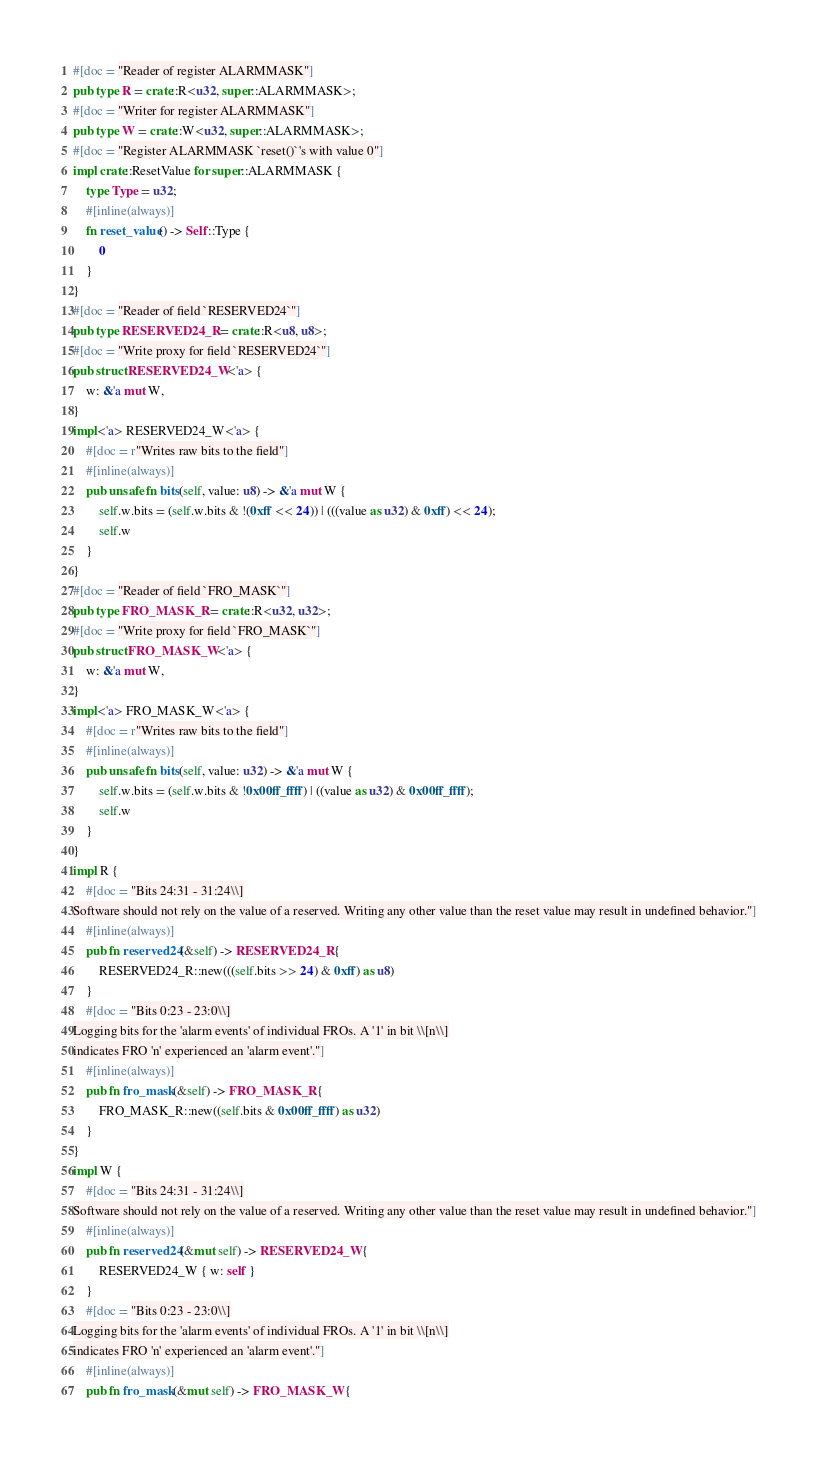<code> <loc_0><loc_0><loc_500><loc_500><_Rust_>#[doc = "Reader of register ALARMMASK"]
pub type R = crate::R<u32, super::ALARMMASK>;
#[doc = "Writer for register ALARMMASK"]
pub type W = crate::W<u32, super::ALARMMASK>;
#[doc = "Register ALARMMASK `reset()`'s with value 0"]
impl crate::ResetValue for super::ALARMMASK {
    type Type = u32;
    #[inline(always)]
    fn reset_value() -> Self::Type {
        0
    }
}
#[doc = "Reader of field `RESERVED24`"]
pub type RESERVED24_R = crate::R<u8, u8>;
#[doc = "Write proxy for field `RESERVED24`"]
pub struct RESERVED24_W<'a> {
    w: &'a mut W,
}
impl<'a> RESERVED24_W<'a> {
    #[doc = r"Writes raw bits to the field"]
    #[inline(always)]
    pub unsafe fn bits(self, value: u8) -> &'a mut W {
        self.w.bits = (self.w.bits & !(0xff << 24)) | (((value as u32) & 0xff) << 24);
        self.w
    }
}
#[doc = "Reader of field `FRO_MASK`"]
pub type FRO_MASK_R = crate::R<u32, u32>;
#[doc = "Write proxy for field `FRO_MASK`"]
pub struct FRO_MASK_W<'a> {
    w: &'a mut W,
}
impl<'a> FRO_MASK_W<'a> {
    #[doc = r"Writes raw bits to the field"]
    #[inline(always)]
    pub unsafe fn bits(self, value: u32) -> &'a mut W {
        self.w.bits = (self.w.bits & !0x00ff_ffff) | ((value as u32) & 0x00ff_ffff);
        self.w
    }
}
impl R {
    #[doc = "Bits 24:31 - 31:24\\]
Software should not rely on the value of a reserved. Writing any other value than the reset value may result in undefined behavior."]
    #[inline(always)]
    pub fn reserved24(&self) -> RESERVED24_R {
        RESERVED24_R::new(((self.bits >> 24) & 0xff) as u8)
    }
    #[doc = "Bits 0:23 - 23:0\\]
Logging bits for the 'alarm events' of individual FROs. A '1' in bit \\[n\\]
indicates FRO 'n' experienced an 'alarm event'."]
    #[inline(always)]
    pub fn fro_mask(&self) -> FRO_MASK_R {
        FRO_MASK_R::new((self.bits & 0x00ff_ffff) as u32)
    }
}
impl W {
    #[doc = "Bits 24:31 - 31:24\\]
Software should not rely on the value of a reserved. Writing any other value than the reset value may result in undefined behavior."]
    #[inline(always)]
    pub fn reserved24(&mut self) -> RESERVED24_W {
        RESERVED24_W { w: self }
    }
    #[doc = "Bits 0:23 - 23:0\\]
Logging bits for the 'alarm events' of individual FROs. A '1' in bit \\[n\\]
indicates FRO 'n' experienced an 'alarm event'."]
    #[inline(always)]
    pub fn fro_mask(&mut self) -> FRO_MASK_W {</code> 